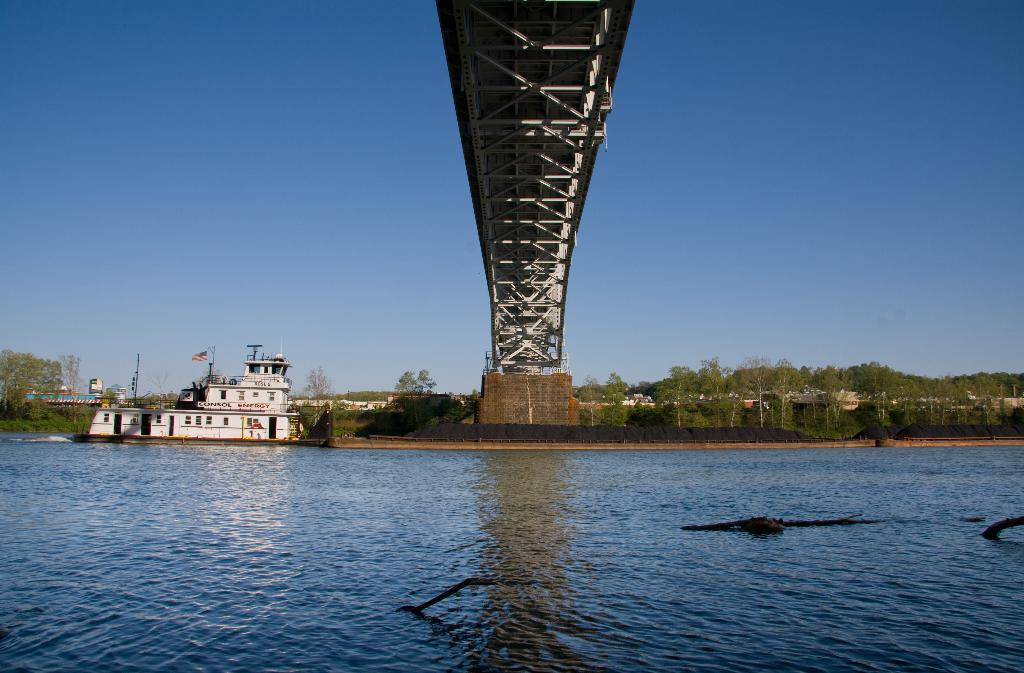What body of water is present in the image? There is a river in the image. What structure is built over the river? There is a bridge above the river. What type of vegetation can be seen behind the river? There are trees visible behind the river. What mode of transportation is on the left side of the image? There is a train on the left side of the image. What large vehicle is present on the river? There is a big ship sailing on the river. Reasoning: Let' Let's think step by step in order to produce the conversation. We start by identifying the main geographical feature in the image, which is the river. Then, we describe the structures and objects that are related to the river, such as the bridge, trees, train, and ship. Each question is designed to elicit a specific detail about the image that is known from the provided facts. Absurd Question/Answer: What type of advertisement can be seen on the glass surface of the ship? There is no advertisement or glass surface present on the ship in the image. 